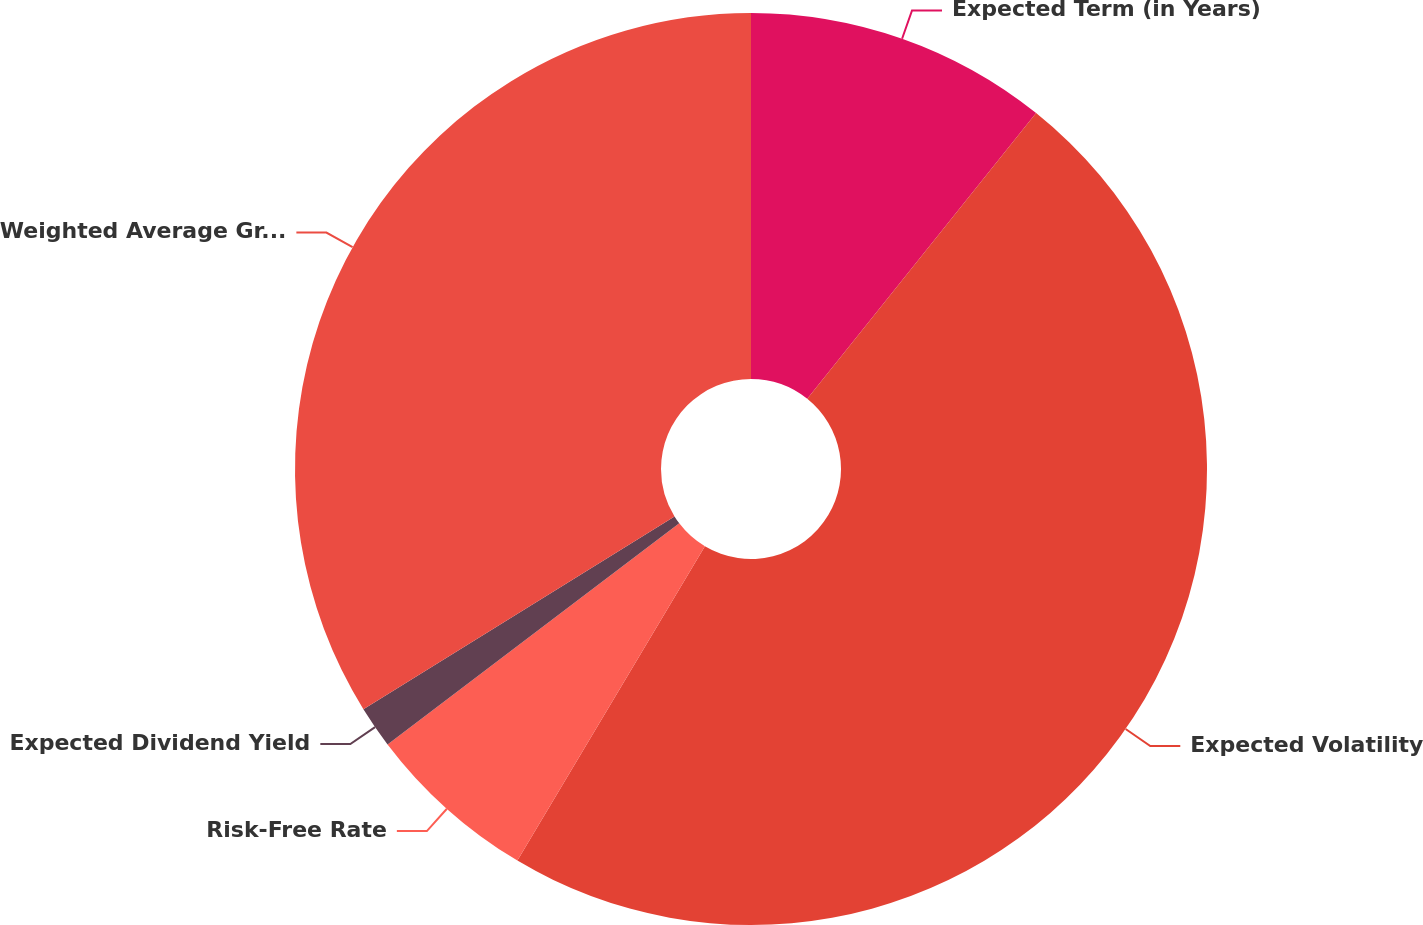<chart> <loc_0><loc_0><loc_500><loc_500><pie_chart><fcel>Expected Term (in Years)<fcel>Expected Volatility<fcel>Risk-Free Rate<fcel>Expected Dividend Yield<fcel>Weighted Average Grant-Date<nl><fcel>10.75%<fcel>47.81%<fcel>6.12%<fcel>1.49%<fcel>33.83%<nl></chart> 